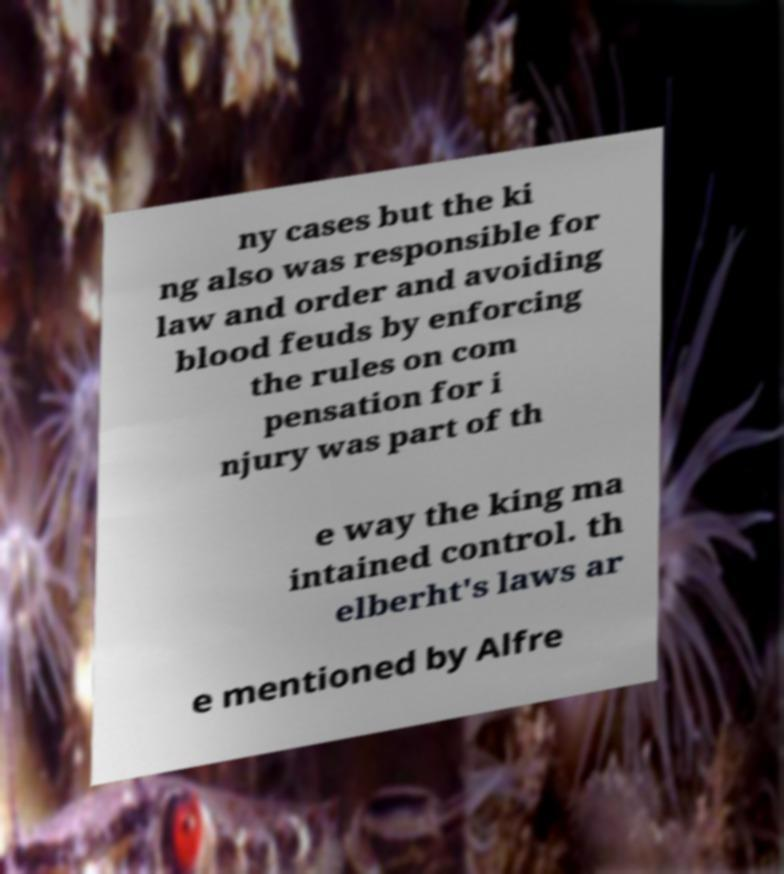I need the written content from this picture converted into text. Can you do that? ny cases but the ki ng also was responsible for law and order and avoiding blood feuds by enforcing the rules on com pensation for i njury was part of th e way the king ma intained control. th elberht's laws ar e mentioned by Alfre 